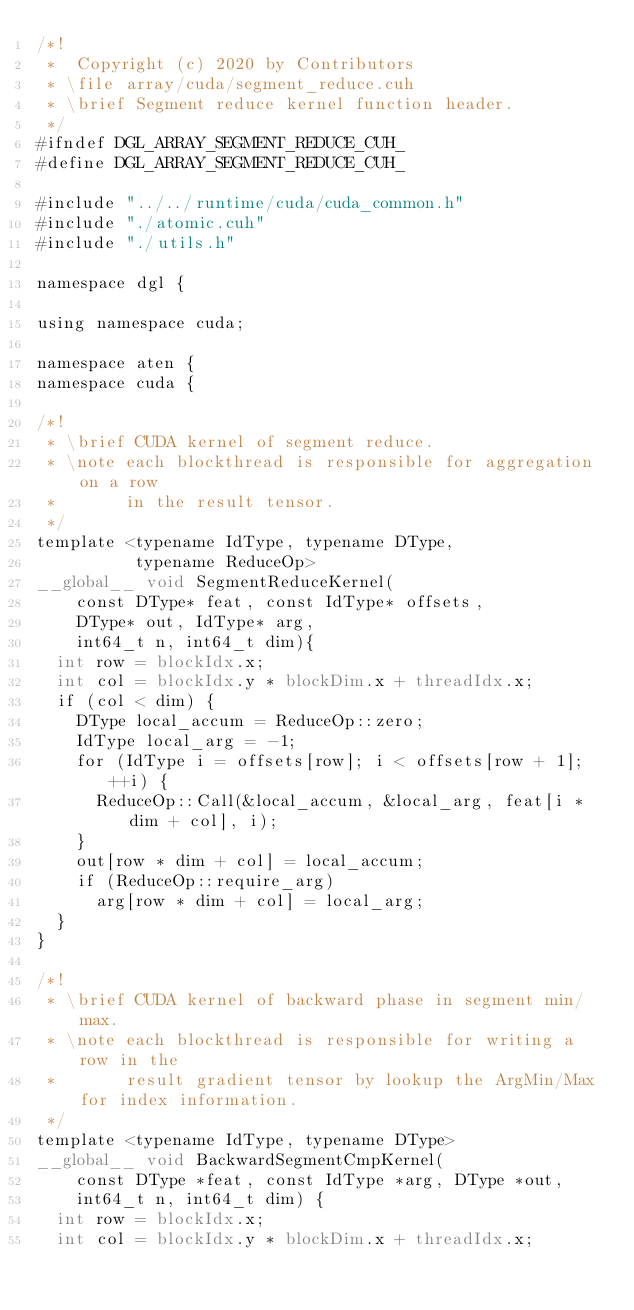Convert code to text. <code><loc_0><loc_0><loc_500><loc_500><_Cuda_>/*!
 *  Copyright (c) 2020 by Contributors
 * \file array/cuda/segment_reduce.cuh
 * \brief Segment reduce kernel function header.
 */
#ifndef DGL_ARRAY_SEGMENT_REDUCE_CUH_
#define DGL_ARRAY_SEGMENT_REDUCE_CUH_

#include "../../runtime/cuda/cuda_common.h"
#include "./atomic.cuh"
#include "./utils.h"

namespace dgl {

using namespace cuda;

namespace aten {
namespace cuda {

/*!
 * \brief CUDA kernel of segment reduce.
 * \note each blockthread is responsible for aggregation on a row
 *       in the result tensor.
 */
template <typename IdType, typename DType,
          typename ReduceOp>
__global__ void SegmentReduceKernel(
    const DType* feat, const IdType* offsets,
    DType* out, IdType* arg,
    int64_t n, int64_t dim){
  int row = blockIdx.x;
  int col = blockIdx.y * blockDim.x + threadIdx.x;
  if (col < dim) {
    DType local_accum = ReduceOp::zero;
    IdType local_arg = -1;
    for (IdType i = offsets[row]; i < offsets[row + 1]; ++i) {
      ReduceOp::Call(&local_accum, &local_arg, feat[i * dim + col], i);
    }
    out[row * dim + col] = local_accum;
    if (ReduceOp::require_arg)
      arg[row * dim + col] = local_arg;
  }
}

/*!
 * \brief CUDA kernel of backward phase in segment min/max.
 * \note each blockthread is responsible for writing a row in the
 *       result gradient tensor by lookup the ArgMin/Max for index information.
 */
template <typename IdType, typename DType>
__global__ void BackwardSegmentCmpKernel(
    const DType *feat, const IdType *arg, DType *out,
    int64_t n, int64_t dim) {
  int row = blockIdx.x;
  int col = blockIdx.y * blockDim.x + threadIdx.x;</code> 